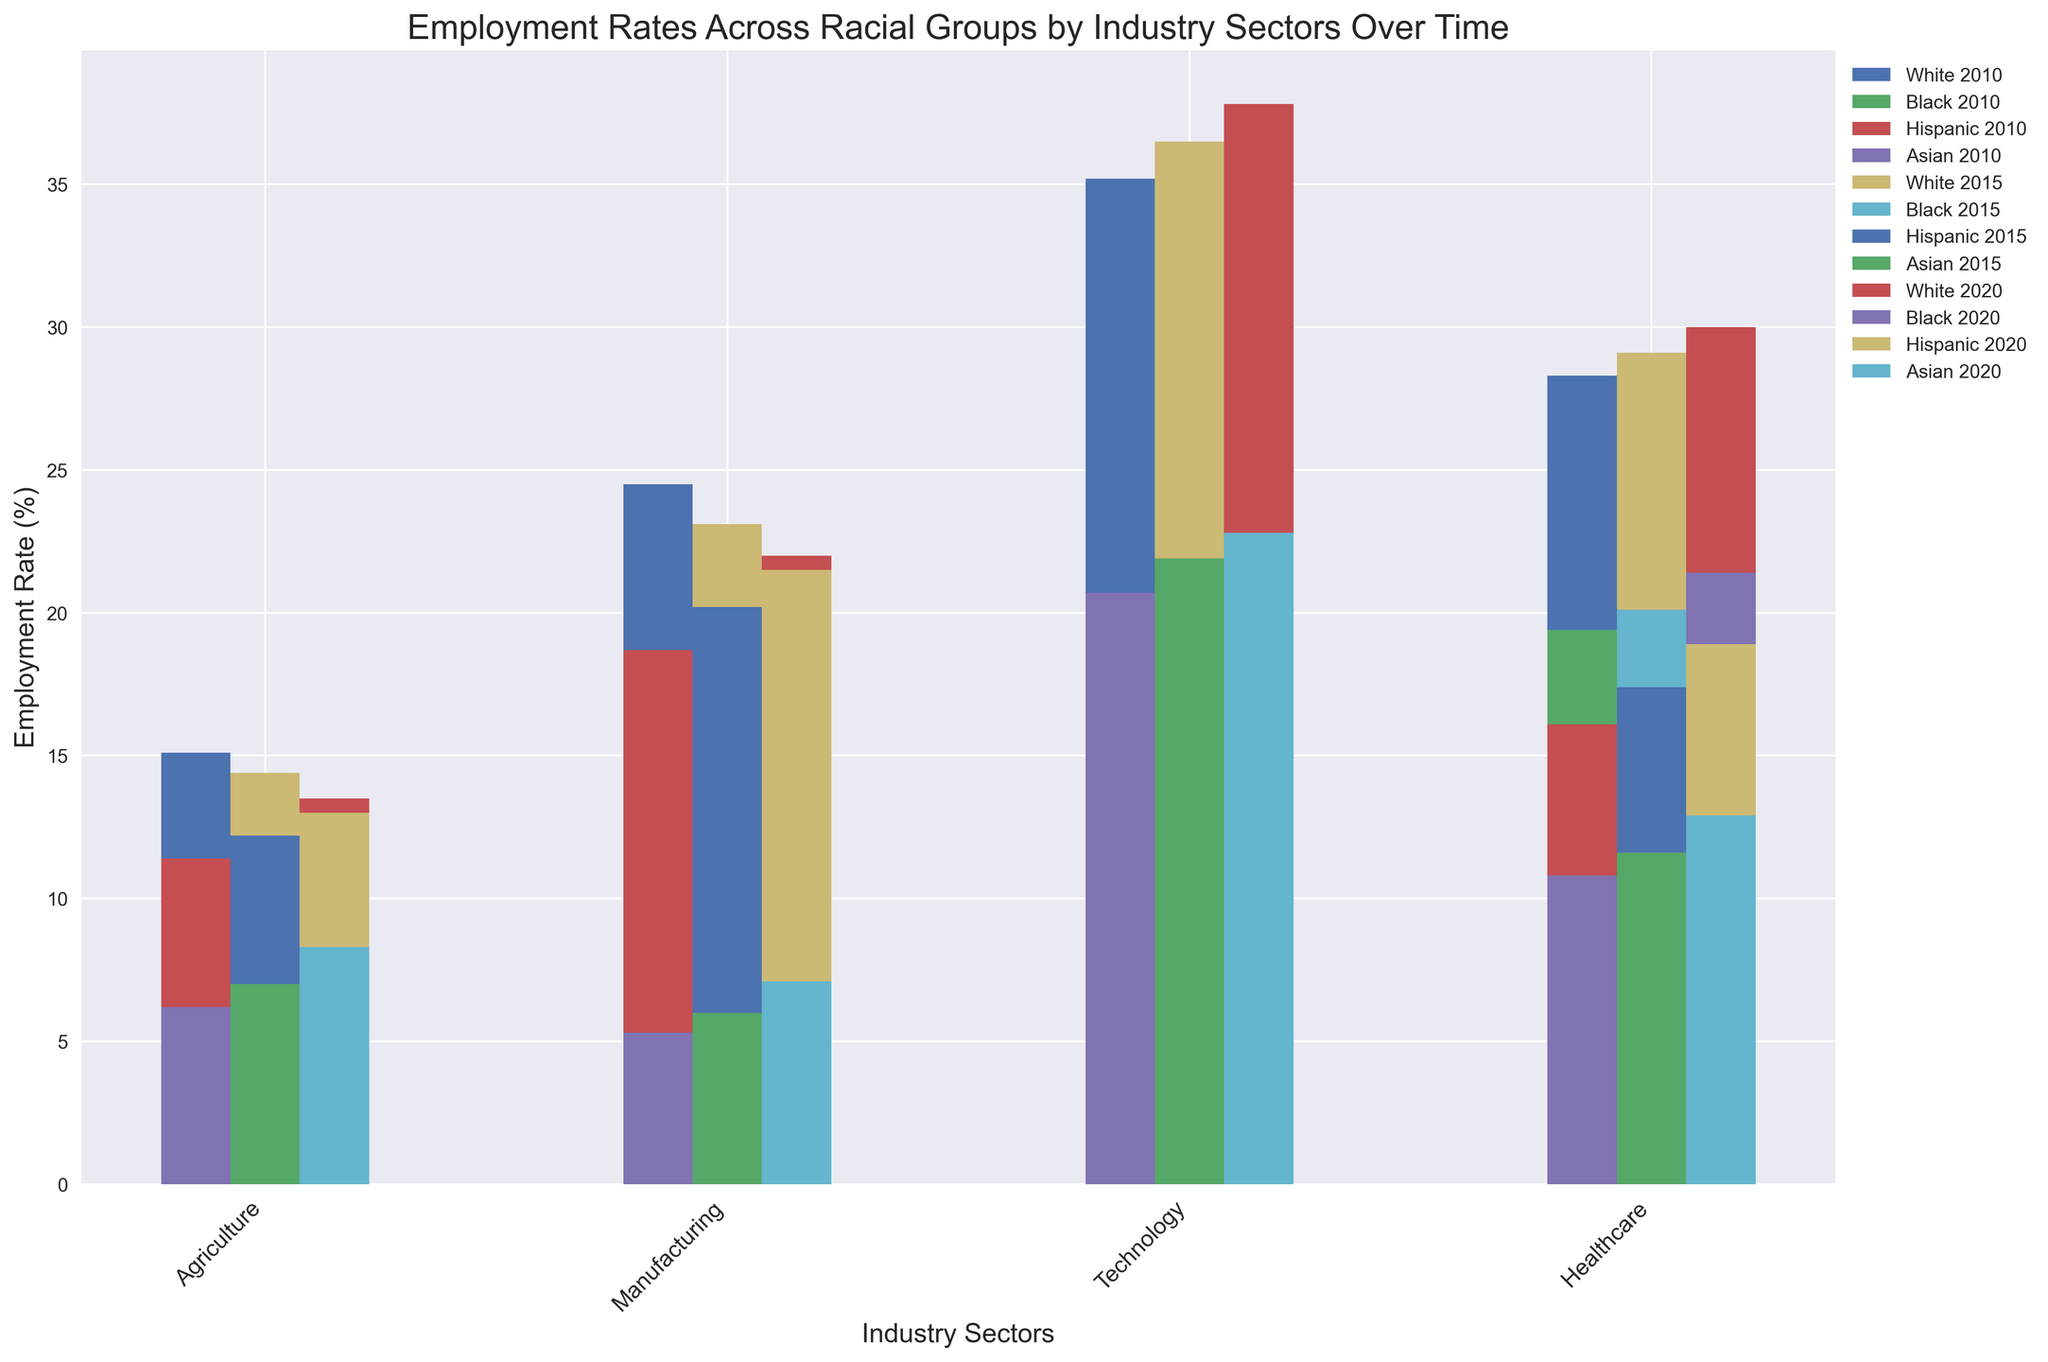Which racial group had the highest employment rate in the Healthcare sector in 2020? Observing the bars for each racial group in the Healthcare sector for the year 2020, the white racial group's bar is the highest.
Answer: White How did the employment rate of Asian workers in the Agriculture sector change from 2010 to 2020? Comparing the heights of the bars representing Asian workers in the Agriculture sector for the years 2010 (6.2), 2015 (7.0), and 2020 (8.3), we can see an increasing trend.
Answer: Increased Between which racial groups and sectors did the employment rates in Technology see the largest gap in 2015? By looking at the heights of the bars for 2015 in the Technology sector, the gap between White (highest at 36.5) and Hispanic (lowest at 6.1) is the largest.
Answer: White and Hispanic What is the average employment rate of Black workers in Manufacturing across all the given years? Sum the employment rates of Black workers in Manufacturing for 2010 (12.8), 2015 (13.6), and 2020 (14.9), then divide by the number of years: (12.8 + 13.6 + 14.9) / 3 = 13.77.
Answer: 13.77 Did the employment rate for Hispanic workers in Agriculture decrease or increase from 2015 to 2020? Looking at the bar heights for Hispanic workers in Agriculture for 2015 (12.2) and 2020 (13.0), we see an increase.
Answer: Increased Which sector showed the most significant increase in employment rates for Black workers from 2010 to 2020? Comparing the heights of the bars in all sectors for Black workers over the years, Healthcare saw an increase from 19.4 (2010) to 21.4 (2020), which is the most significant change.
Answer: Healthcare Which racial group had the lowest employment rate in the Technology sector in 2010? Observing the bars for different racial groups in the Technology sector in 2010, Hispanic workers had the lowest employment rate (5.4).
Answer: Hispanic In which industry sector did White workers see a decrease in employment rate from 2015 to 2020? Reviewing the White workers' bars in different sectors for the years 2015 and 2020, Agriculture shows a decrease from 14.4 to 13.5.
Answer: Agriculture What was the difference in employment rates between Asian and Black workers in the Healthcare sector in 2020? Subtract the employment rate of Asian workers (12.9) from that of Black workers (21.4) in the Healthcare sector for 2020: 21.4 - 12.9 = 8.5.
Answer: 8.5 